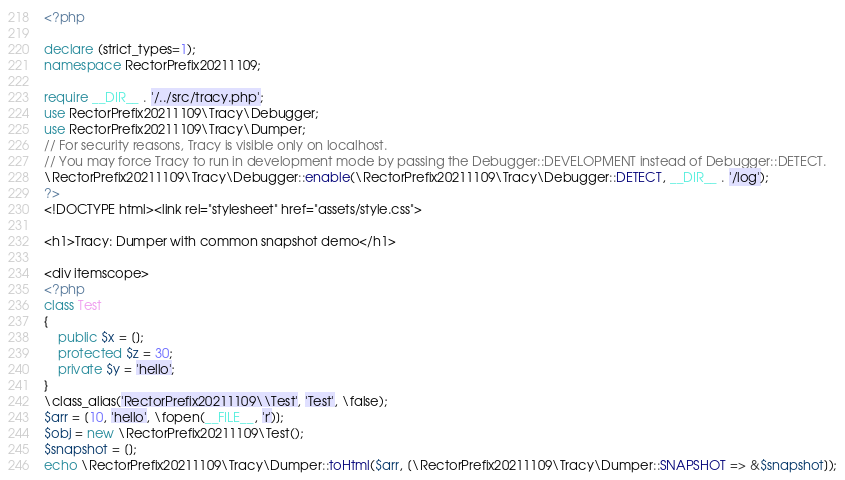<code> <loc_0><loc_0><loc_500><loc_500><_PHP_><?php

declare (strict_types=1);
namespace RectorPrefix20211109;

require __DIR__ . '/../src/tracy.php';
use RectorPrefix20211109\Tracy\Debugger;
use RectorPrefix20211109\Tracy\Dumper;
// For security reasons, Tracy is visible only on localhost.
// You may force Tracy to run in development mode by passing the Debugger::DEVELOPMENT instead of Debugger::DETECT.
\RectorPrefix20211109\Tracy\Debugger::enable(\RectorPrefix20211109\Tracy\Debugger::DETECT, __DIR__ . '/log');
?>
<!DOCTYPE html><link rel="stylesheet" href="assets/style.css">

<h1>Tracy: Dumper with common snapshot demo</h1>

<div itemscope>
<?php 
class Test
{
    public $x = [];
    protected $z = 30;
    private $y = 'hello';
}
\class_alias('RectorPrefix20211109\\Test', 'Test', \false);
$arr = [10, 'hello', \fopen(__FILE__, 'r')];
$obj = new \RectorPrefix20211109\Test();
$snapshot = [];
echo \RectorPrefix20211109\Tracy\Dumper::toHtml($arr, [\RectorPrefix20211109\Tracy\Dumper::SNAPSHOT => &$snapshot]);</code> 